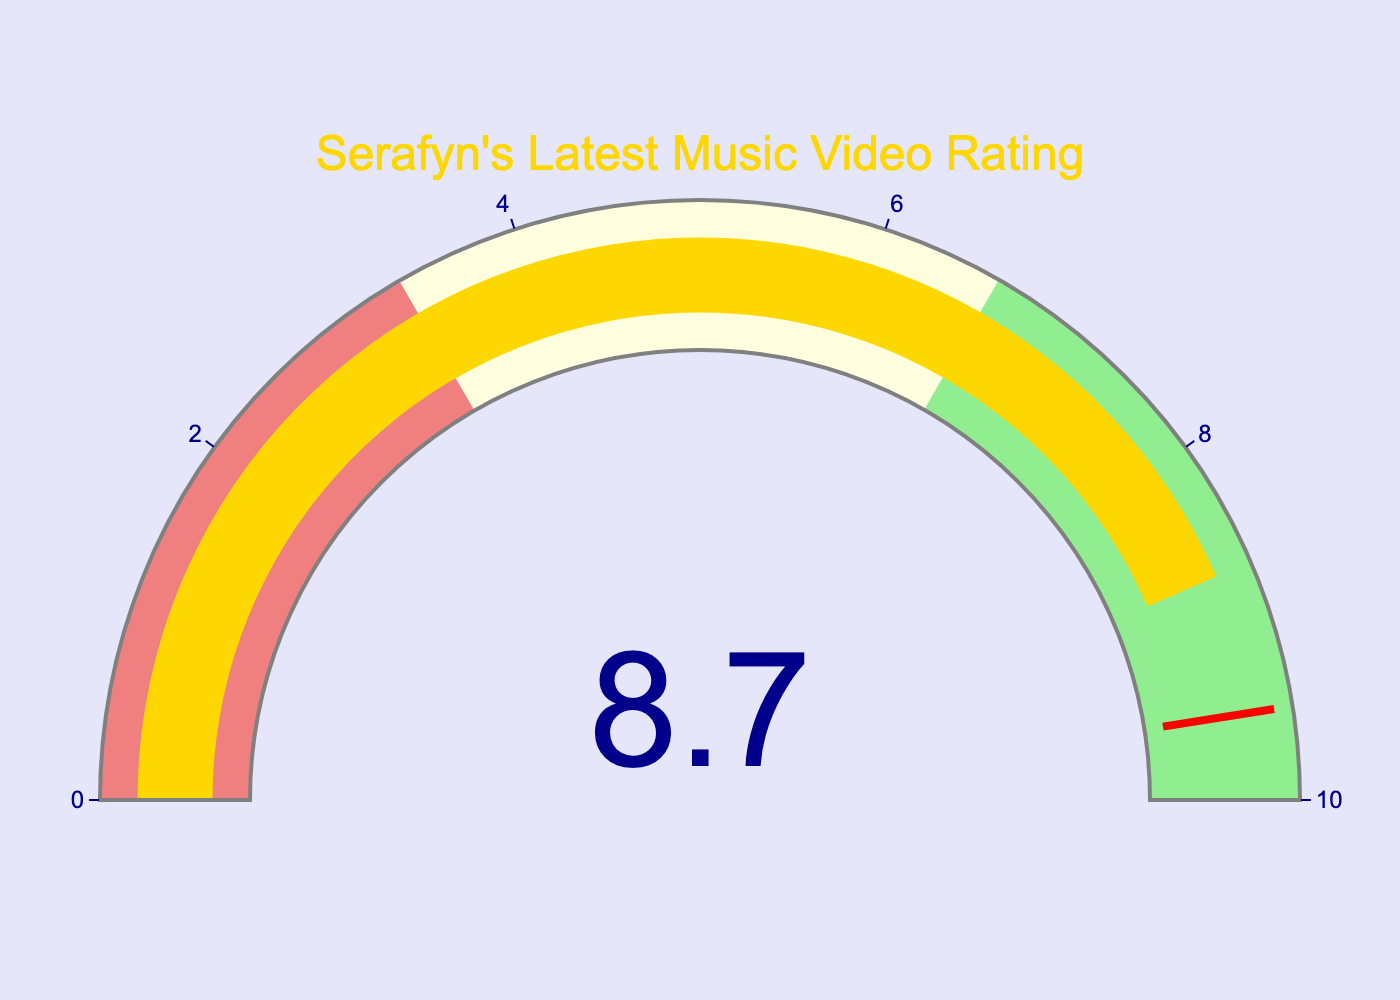What is the average viewer rating of Serafyn's latest music video as shown in the gauge? The gauge shows a value indicated by a number at the center of the figure. In this case, the number is 8.7.
Answer: 8.7 What is the range of the gauge? The gauge has indicators showing the minimum and maximum values. In this case, the axis of the gauge shows a range from 0 to 10.
Answer: 0-10 What color indicates a rating between 6.66 and 10? The different sections of the gauge are colored differently. From 6.66 to 10, it is colored in light green.
Answer: Light green How close is the average rating to the threshold value? The gauge has a threshold at 9.5, and the displayed average rating is 8.7, so the difference is 9.5 - 8.7 = 0.8. The rating is 0.8 units below the threshold.
Answer: 0.8 units below Which color range does the average viewer rating fall into? The gauge is divided into three color ranges: light coral (0 to 3.33), light yellow (3.33 to 6.66), and light green (6.66 to 10). The average viewer rating of 8.7 falls within the light green range.
Answer: Light green What is the title shown at the top of the gauge? The title is displayed at the top of the gauge in bold, indicating the context of the figure. It reads "Serafyn's Latest Music Video Rating".
Answer: Serafyn's Latest Music Video Rating Does the gauge have a background color? If so, what is it? The gauge has a background color indicated around the gauge section. In this case, the background color of the figure is white.
Answer: White What does the red line in the gauge represent? The red line in the gauge represents a threshold value. It is drawn at a value of 9.5 which indicates a critical benchmark or target value.
Answer: Threshold value How does the average viewer rating of 8.7 compare to the highest possible rating? The highest possible rating on the gauge is 10. Comparing 8.7 to 10, 8.7 is less than 10, but quite close.
Answer: Less than 10 What is the position of the needle of the gauge relative to the sections of the gauge? The needle of the gauge is pointing towards the section between 6.66 and 10 which is colored in light green. This corresponds to the average viewer rating of 8.7.
Answer: Between 6.66 and 10 